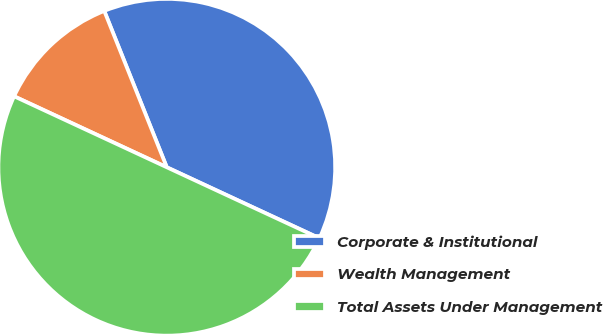Convert chart. <chart><loc_0><loc_0><loc_500><loc_500><pie_chart><fcel>Corporate & Institutional<fcel>Wealth Management<fcel>Total Assets Under Management<nl><fcel>37.98%<fcel>12.02%<fcel>50.0%<nl></chart> 